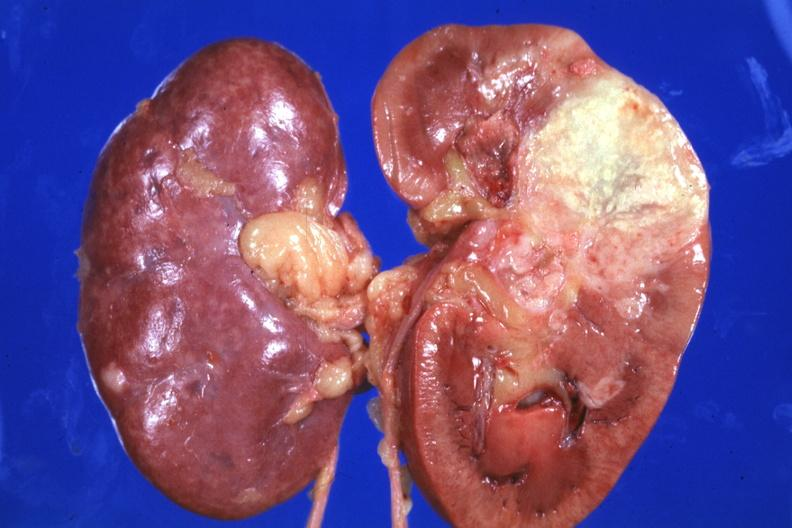what is present?
Answer the question using a single word or phrase. Kidney 